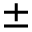Convert formula to latex. <formula><loc_0><loc_0><loc_500><loc_500>\pm</formula> 